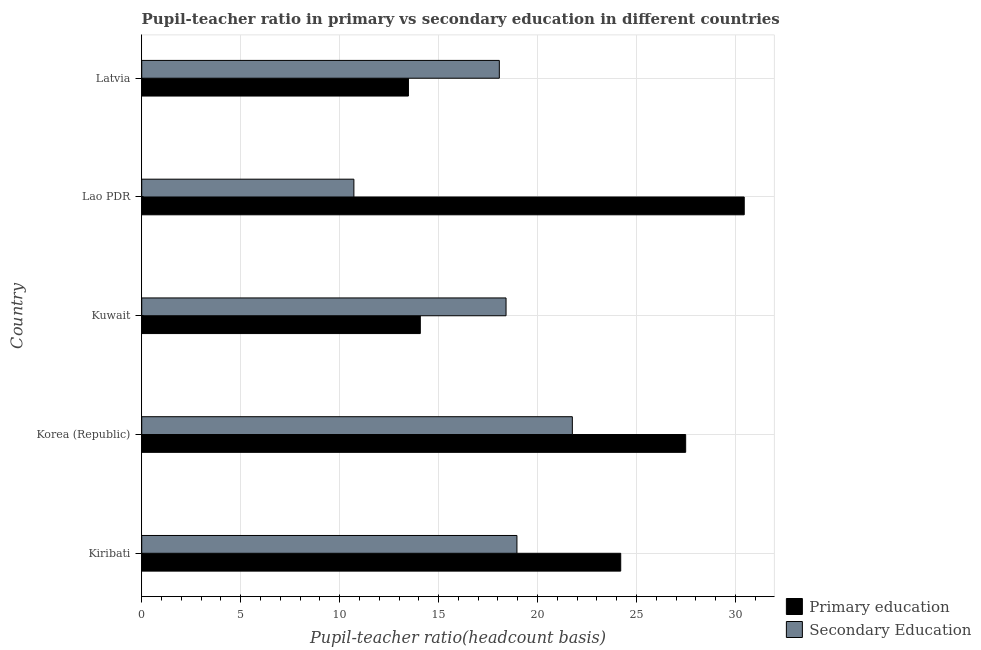How many different coloured bars are there?
Keep it short and to the point. 2. Are the number of bars on each tick of the Y-axis equal?
Keep it short and to the point. Yes. How many bars are there on the 4th tick from the top?
Provide a succinct answer. 2. How many bars are there on the 3rd tick from the bottom?
Make the answer very short. 2. What is the label of the 2nd group of bars from the top?
Provide a succinct answer. Lao PDR. What is the pupil-teacher ratio in primary education in Korea (Republic)?
Give a very brief answer. 27.48. Across all countries, what is the maximum pupil-teacher ratio in primary education?
Keep it short and to the point. 30.44. Across all countries, what is the minimum pupil teacher ratio on secondary education?
Your answer should be very brief. 10.72. In which country was the pupil teacher ratio on secondary education maximum?
Your answer should be very brief. Korea (Republic). In which country was the pupil teacher ratio on secondary education minimum?
Keep it short and to the point. Lao PDR. What is the total pupil-teacher ratio in primary education in the graph?
Ensure brevity in your answer.  109.68. What is the difference between the pupil-teacher ratio in primary education in Korea (Republic) and that in Kuwait?
Your response must be concise. 13.41. What is the difference between the pupil-teacher ratio in primary education in Latvia and the pupil teacher ratio on secondary education in Korea (Republic)?
Ensure brevity in your answer.  -8.28. What is the average pupil teacher ratio on secondary education per country?
Keep it short and to the point. 17.58. What is the difference between the pupil teacher ratio on secondary education and pupil-teacher ratio in primary education in Latvia?
Your answer should be very brief. 4.59. What is the ratio of the pupil-teacher ratio in primary education in Korea (Republic) to that in Latvia?
Offer a terse response. 2.04. What is the difference between the highest and the second highest pupil-teacher ratio in primary education?
Offer a terse response. 2.96. What is the difference between the highest and the lowest pupil-teacher ratio in primary education?
Provide a succinct answer. 16.97. What does the 1st bar from the top in Latvia represents?
Offer a very short reply. Secondary Education. What does the 2nd bar from the bottom in Kuwait represents?
Offer a terse response. Secondary Education. How many countries are there in the graph?
Your answer should be compact. 5. What is the difference between two consecutive major ticks on the X-axis?
Offer a very short reply. 5. How many legend labels are there?
Give a very brief answer. 2. What is the title of the graph?
Provide a short and direct response. Pupil-teacher ratio in primary vs secondary education in different countries. Does "Fixed telephone" appear as one of the legend labels in the graph?
Provide a succinct answer. No. What is the label or title of the X-axis?
Your response must be concise. Pupil-teacher ratio(headcount basis). What is the Pupil-teacher ratio(headcount basis) of Primary education in Kiribati?
Ensure brevity in your answer.  24.2. What is the Pupil-teacher ratio(headcount basis) of Secondary Education in Kiribati?
Give a very brief answer. 18.96. What is the Pupil-teacher ratio(headcount basis) in Primary education in Korea (Republic)?
Make the answer very short. 27.48. What is the Pupil-teacher ratio(headcount basis) of Secondary Education in Korea (Republic)?
Your answer should be compact. 21.76. What is the Pupil-teacher ratio(headcount basis) of Primary education in Kuwait?
Offer a very short reply. 14.08. What is the Pupil-teacher ratio(headcount basis) in Secondary Education in Kuwait?
Offer a terse response. 18.41. What is the Pupil-teacher ratio(headcount basis) in Primary education in Lao PDR?
Provide a succinct answer. 30.44. What is the Pupil-teacher ratio(headcount basis) of Secondary Education in Lao PDR?
Offer a very short reply. 10.72. What is the Pupil-teacher ratio(headcount basis) in Primary education in Latvia?
Offer a very short reply. 13.48. What is the Pupil-teacher ratio(headcount basis) of Secondary Education in Latvia?
Your answer should be very brief. 18.07. Across all countries, what is the maximum Pupil-teacher ratio(headcount basis) of Primary education?
Offer a very short reply. 30.44. Across all countries, what is the maximum Pupil-teacher ratio(headcount basis) in Secondary Education?
Give a very brief answer. 21.76. Across all countries, what is the minimum Pupil-teacher ratio(headcount basis) in Primary education?
Keep it short and to the point. 13.48. Across all countries, what is the minimum Pupil-teacher ratio(headcount basis) in Secondary Education?
Your answer should be very brief. 10.72. What is the total Pupil-teacher ratio(headcount basis) in Primary education in the graph?
Your response must be concise. 109.67. What is the total Pupil-teacher ratio(headcount basis) in Secondary Education in the graph?
Your response must be concise. 87.91. What is the difference between the Pupil-teacher ratio(headcount basis) of Primary education in Kiribati and that in Korea (Republic)?
Ensure brevity in your answer.  -3.28. What is the difference between the Pupil-teacher ratio(headcount basis) in Secondary Education in Kiribati and that in Korea (Republic)?
Ensure brevity in your answer.  -2.8. What is the difference between the Pupil-teacher ratio(headcount basis) in Primary education in Kiribati and that in Kuwait?
Keep it short and to the point. 10.13. What is the difference between the Pupil-teacher ratio(headcount basis) in Secondary Education in Kiribati and that in Kuwait?
Your response must be concise. 0.55. What is the difference between the Pupil-teacher ratio(headcount basis) of Primary education in Kiribati and that in Lao PDR?
Offer a very short reply. -6.24. What is the difference between the Pupil-teacher ratio(headcount basis) in Secondary Education in Kiribati and that in Lao PDR?
Give a very brief answer. 8.24. What is the difference between the Pupil-teacher ratio(headcount basis) in Primary education in Kiribati and that in Latvia?
Offer a terse response. 10.73. What is the difference between the Pupil-teacher ratio(headcount basis) in Secondary Education in Kiribati and that in Latvia?
Your answer should be very brief. 0.89. What is the difference between the Pupil-teacher ratio(headcount basis) of Primary education in Korea (Republic) and that in Kuwait?
Offer a terse response. 13.41. What is the difference between the Pupil-teacher ratio(headcount basis) of Secondary Education in Korea (Republic) and that in Kuwait?
Ensure brevity in your answer.  3.35. What is the difference between the Pupil-teacher ratio(headcount basis) in Primary education in Korea (Republic) and that in Lao PDR?
Offer a terse response. -2.96. What is the difference between the Pupil-teacher ratio(headcount basis) in Secondary Education in Korea (Republic) and that in Lao PDR?
Your answer should be very brief. 11.04. What is the difference between the Pupil-teacher ratio(headcount basis) of Primary education in Korea (Republic) and that in Latvia?
Give a very brief answer. 14.01. What is the difference between the Pupil-teacher ratio(headcount basis) in Secondary Education in Korea (Republic) and that in Latvia?
Make the answer very short. 3.69. What is the difference between the Pupil-teacher ratio(headcount basis) of Primary education in Kuwait and that in Lao PDR?
Your answer should be compact. -16.37. What is the difference between the Pupil-teacher ratio(headcount basis) in Secondary Education in Kuwait and that in Lao PDR?
Provide a short and direct response. 7.69. What is the difference between the Pupil-teacher ratio(headcount basis) in Primary education in Kuwait and that in Latvia?
Provide a succinct answer. 0.6. What is the difference between the Pupil-teacher ratio(headcount basis) in Secondary Education in Kuwait and that in Latvia?
Offer a terse response. 0.34. What is the difference between the Pupil-teacher ratio(headcount basis) of Primary education in Lao PDR and that in Latvia?
Offer a very short reply. 16.97. What is the difference between the Pupil-teacher ratio(headcount basis) in Secondary Education in Lao PDR and that in Latvia?
Provide a short and direct response. -7.35. What is the difference between the Pupil-teacher ratio(headcount basis) in Primary education in Kiribati and the Pupil-teacher ratio(headcount basis) in Secondary Education in Korea (Republic)?
Keep it short and to the point. 2.44. What is the difference between the Pupil-teacher ratio(headcount basis) of Primary education in Kiribati and the Pupil-teacher ratio(headcount basis) of Secondary Education in Kuwait?
Give a very brief answer. 5.79. What is the difference between the Pupil-teacher ratio(headcount basis) in Primary education in Kiribati and the Pupil-teacher ratio(headcount basis) in Secondary Education in Lao PDR?
Provide a short and direct response. 13.48. What is the difference between the Pupil-teacher ratio(headcount basis) of Primary education in Kiribati and the Pupil-teacher ratio(headcount basis) of Secondary Education in Latvia?
Ensure brevity in your answer.  6.13. What is the difference between the Pupil-teacher ratio(headcount basis) in Primary education in Korea (Republic) and the Pupil-teacher ratio(headcount basis) in Secondary Education in Kuwait?
Make the answer very short. 9.08. What is the difference between the Pupil-teacher ratio(headcount basis) of Primary education in Korea (Republic) and the Pupil-teacher ratio(headcount basis) of Secondary Education in Lao PDR?
Your response must be concise. 16.76. What is the difference between the Pupil-teacher ratio(headcount basis) of Primary education in Korea (Republic) and the Pupil-teacher ratio(headcount basis) of Secondary Education in Latvia?
Offer a very short reply. 9.41. What is the difference between the Pupil-teacher ratio(headcount basis) of Primary education in Kuwait and the Pupil-teacher ratio(headcount basis) of Secondary Education in Lao PDR?
Your answer should be very brief. 3.36. What is the difference between the Pupil-teacher ratio(headcount basis) in Primary education in Kuwait and the Pupil-teacher ratio(headcount basis) in Secondary Education in Latvia?
Your answer should be compact. -3.99. What is the difference between the Pupil-teacher ratio(headcount basis) of Primary education in Lao PDR and the Pupil-teacher ratio(headcount basis) of Secondary Education in Latvia?
Make the answer very short. 12.37. What is the average Pupil-teacher ratio(headcount basis) in Primary education per country?
Make the answer very short. 21.93. What is the average Pupil-teacher ratio(headcount basis) of Secondary Education per country?
Ensure brevity in your answer.  17.58. What is the difference between the Pupil-teacher ratio(headcount basis) in Primary education and Pupil-teacher ratio(headcount basis) in Secondary Education in Kiribati?
Make the answer very short. 5.24. What is the difference between the Pupil-teacher ratio(headcount basis) of Primary education and Pupil-teacher ratio(headcount basis) of Secondary Education in Korea (Republic)?
Offer a terse response. 5.73. What is the difference between the Pupil-teacher ratio(headcount basis) of Primary education and Pupil-teacher ratio(headcount basis) of Secondary Education in Kuwait?
Provide a short and direct response. -4.33. What is the difference between the Pupil-teacher ratio(headcount basis) of Primary education and Pupil-teacher ratio(headcount basis) of Secondary Education in Lao PDR?
Your answer should be very brief. 19.72. What is the difference between the Pupil-teacher ratio(headcount basis) of Primary education and Pupil-teacher ratio(headcount basis) of Secondary Education in Latvia?
Your response must be concise. -4.59. What is the ratio of the Pupil-teacher ratio(headcount basis) in Primary education in Kiribati to that in Korea (Republic)?
Provide a short and direct response. 0.88. What is the ratio of the Pupil-teacher ratio(headcount basis) in Secondary Education in Kiribati to that in Korea (Republic)?
Give a very brief answer. 0.87. What is the ratio of the Pupil-teacher ratio(headcount basis) in Primary education in Kiribati to that in Kuwait?
Provide a succinct answer. 1.72. What is the ratio of the Pupil-teacher ratio(headcount basis) in Secondary Education in Kiribati to that in Kuwait?
Your answer should be very brief. 1.03. What is the ratio of the Pupil-teacher ratio(headcount basis) in Primary education in Kiribati to that in Lao PDR?
Ensure brevity in your answer.  0.8. What is the ratio of the Pupil-teacher ratio(headcount basis) of Secondary Education in Kiribati to that in Lao PDR?
Make the answer very short. 1.77. What is the ratio of the Pupil-teacher ratio(headcount basis) of Primary education in Kiribati to that in Latvia?
Ensure brevity in your answer.  1.8. What is the ratio of the Pupil-teacher ratio(headcount basis) in Secondary Education in Kiribati to that in Latvia?
Offer a very short reply. 1.05. What is the ratio of the Pupil-teacher ratio(headcount basis) in Primary education in Korea (Republic) to that in Kuwait?
Offer a terse response. 1.95. What is the ratio of the Pupil-teacher ratio(headcount basis) in Secondary Education in Korea (Republic) to that in Kuwait?
Your response must be concise. 1.18. What is the ratio of the Pupil-teacher ratio(headcount basis) in Primary education in Korea (Republic) to that in Lao PDR?
Provide a short and direct response. 0.9. What is the ratio of the Pupil-teacher ratio(headcount basis) in Secondary Education in Korea (Republic) to that in Lao PDR?
Provide a succinct answer. 2.03. What is the ratio of the Pupil-teacher ratio(headcount basis) of Primary education in Korea (Republic) to that in Latvia?
Offer a very short reply. 2.04. What is the ratio of the Pupil-teacher ratio(headcount basis) of Secondary Education in Korea (Republic) to that in Latvia?
Keep it short and to the point. 1.2. What is the ratio of the Pupil-teacher ratio(headcount basis) of Primary education in Kuwait to that in Lao PDR?
Your answer should be very brief. 0.46. What is the ratio of the Pupil-teacher ratio(headcount basis) of Secondary Education in Kuwait to that in Lao PDR?
Offer a very short reply. 1.72. What is the ratio of the Pupil-teacher ratio(headcount basis) in Primary education in Kuwait to that in Latvia?
Provide a short and direct response. 1.04. What is the ratio of the Pupil-teacher ratio(headcount basis) of Secondary Education in Kuwait to that in Latvia?
Offer a very short reply. 1.02. What is the ratio of the Pupil-teacher ratio(headcount basis) in Primary education in Lao PDR to that in Latvia?
Offer a very short reply. 2.26. What is the ratio of the Pupil-teacher ratio(headcount basis) of Secondary Education in Lao PDR to that in Latvia?
Your answer should be very brief. 0.59. What is the difference between the highest and the second highest Pupil-teacher ratio(headcount basis) of Primary education?
Offer a very short reply. 2.96. What is the difference between the highest and the second highest Pupil-teacher ratio(headcount basis) in Secondary Education?
Offer a terse response. 2.8. What is the difference between the highest and the lowest Pupil-teacher ratio(headcount basis) of Primary education?
Offer a very short reply. 16.97. What is the difference between the highest and the lowest Pupil-teacher ratio(headcount basis) in Secondary Education?
Provide a succinct answer. 11.04. 